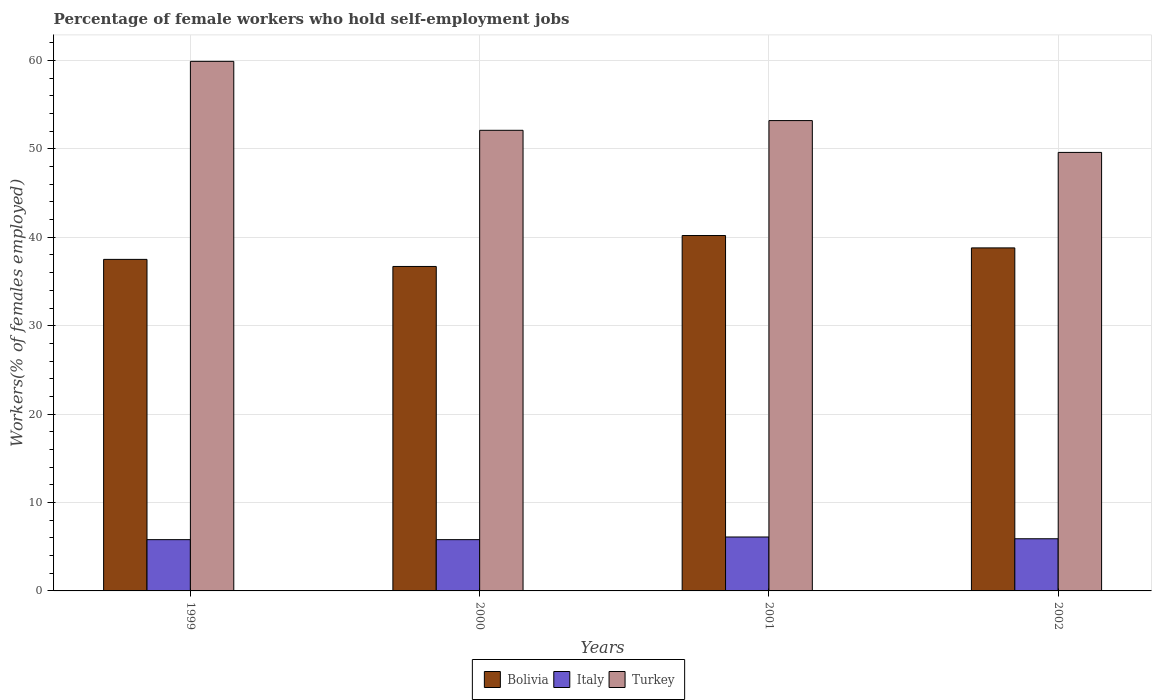How many different coloured bars are there?
Keep it short and to the point. 3. Are the number of bars on each tick of the X-axis equal?
Offer a terse response. Yes. How many bars are there on the 4th tick from the right?
Keep it short and to the point. 3. What is the percentage of self-employed female workers in Bolivia in 2001?
Your answer should be compact. 40.2. Across all years, what is the maximum percentage of self-employed female workers in Bolivia?
Your answer should be very brief. 40.2. Across all years, what is the minimum percentage of self-employed female workers in Italy?
Your answer should be very brief. 5.8. What is the total percentage of self-employed female workers in Turkey in the graph?
Make the answer very short. 214.8. What is the difference between the percentage of self-employed female workers in Turkey in 2000 and that in 2001?
Provide a succinct answer. -1.1. What is the difference between the percentage of self-employed female workers in Bolivia in 2000 and the percentage of self-employed female workers in Turkey in 2002?
Provide a short and direct response. -12.9. What is the average percentage of self-employed female workers in Bolivia per year?
Your answer should be very brief. 38.3. In the year 2000, what is the difference between the percentage of self-employed female workers in Turkey and percentage of self-employed female workers in Bolivia?
Make the answer very short. 15.4. In how many years, is the percentage of self-employed female workers in Turkey greater than 30 %?
Ensure brevity in your answer.  4. What is the ratio of the percentage of self-employed female workers in Bolivia in 1999 to that in 2000?
Your response must be concise. 1.02. Is the percentage of self-employed female workers in Italy in 2000 less than that in 2001?
Offer a very short reply. Yes. What is the difference between the highest and the second highest percentage of self-employed female workers in Italy?
Provide a succinct answer. 0.2. What does the 3rd bar from the right in 2000 represents?
Provide a short and direct response. Bolivia. Is it the case that in every year, the sum of the percentage of self-employed female workers in Turkey and percentage of self-employed female workers in Bolivia is greater than the percentage of self-employed female workers in Italy?
Your response must be concise. Yes. Are all the bars in the graph horizontal?
Provide a short and direct response. No. Does the graph contain any zero values?
Offer a terse response. No. Does the graph contain grids?
Offer a very short reply. Yes. How many legend labels are there?
Your answer should be compact. 3. How are the legend labels stacked?
Ensure brevity in your answer.  Horizontal. What is the title of the graph?
Ensure brevity in your answer.  Percentage of female workers who hold self-employment jobs. Does "Algeria" appear as one of the legend labels in the graph?
Keep it short and to the point. No. What is the label or title of the X-axis?
Ensure brevity in your answer.  Years. What is the label or title of the Y-axis?
Your response must be concise. Workers(% of females employed). What is the Workers(% of females employed) of Bolivia in 1999?
Provide a succinct answer. 37.5. What is the Workers(% of females employed) in Italy in 1999?
Your response must be concise. 5.8. What is the Workers(% of females employed) in Turkey in 1999?
Provide a short and direct response. 59.9. What is the Workers(% of females employed) of Bolivia in 2000?
Your answer should be very brief. 36.7. What is the Workers(% of females employed) of Italy in 2000?
Provide a succinct answer. 5.8. What is the Workers(% of females employed) in Turkey in 2000?
Offer a very short reply. 52.1. What is the Workers(% of females employed) of Bolivia in 2001?
Offer a very short reply. 40.2. What is the Workers(% of females employed) in Italy in 2001?
Provide a succinct answer. 6.1. What is the Workers(% of females employed) of Turkey in 2001?
Ensure brevity in your answer.  53.2. What is the Workers(% of females employed) in Bolivia in 2002?
Give a very brief answer. 38.8. What is the Workers(% of females employed) in Italy in 2002?
Make the answer very short. 5.9. What is the Workers(% of females employed) of Turkey in 2002?
Your answer should be compact. 49.6. Across all years, what is the maximum Workers(% of females employed) of Bolivia?
Your answer should be very brief. 40.2. Across all years, what is the maximum Workers(% of females employed) in Italy?
Ensure brevity in your answer.  6.1. Across all years, what is the maximum Workers(% of females employed) of Turkey?
Your answer should be very brief. 59.9. Across all years, what is the minimum Workers(% of females employed) of Bolivia?
Make the answer very short. 36.7. Across all years, what is the minimum Workers(% of females employed) of Italy?
Give a very brief answer. 5.8. Across all years, what is the minimum Workers(% of females employed) of Turkey?
Offer a very short reply. 49.6. What is the total Workers(% of females employed) of Bolivia in the graph?
Keep it short and to the point. 153.2. What is the total Workers(% of females employed) of Italy in the graph?
Make the answer very short. 23.6. What is the total Workers(% of females employed) of Turkey in the graph?
Give a very brief answer. 214.8. What is the difference between the Workers(% of females employed) in Bolivia in 1999 and that in 2000?
Offer a very short reply. 0.8. What is the difference between the Workers(% of females employed) of Turkey in 1999 and that in 2000?
Your response must be concise. 7.8. What is the difference between the Workers(% of females employed) of Italy in 1999 and that in 2001?
Give a very brief answer. -0.3. What is the difference between the Workers(% of females employed) in Turkey in 1999 and that in 2001?
Your answer should be very brief. 6.7. What is the difference between the Workers(% of females employed) of Bolivia in 1999 and that in 2002?
Keep it short and to the point. -1.3. What is the difference between the Workers(% of females employed) of Bolivia in 2000 and that in 2001?
Offer a terse response. -3.5. What is the difference between the Workers(% of females employed) in Italy in 2000 and that in 2001?
Ensure brevity in your answer.  -0.3. What is the difference between the Workers(% of females employed) of Bolivia in 2000 and that in 2002?
Your response must be concise. -2.1. What is the difference between the Workers(% of females employed) in Italy in 2000 and that in 2002?
Keep it short and to the point. -0.1. What is the difference between the Workers(% of females employed) in Turkey in 2001 and that in 2002?
Keep it short and to the point. 3.6. What is the difference between the Workers(% of females employed) of Bolivia in 1999 and the Workers(% of females employed) of Italy in 2000?
Your response must be concise. 31.7. What is the difference between the Workers(% of females employed) of Bolivia in 1999 and the Workers(% of females employed) of Turkey in 2000?
Provide a short and direct response. -14.6. What is the difference between the Workers(% of females employed) in Italy in 1999 and the Workers(% of females employed) in Turkey in 2000?
Offer a very short reply. -46.3. What is the difference between the Workers(% of females employed) in Bolivia in 1999 and the Workers(% of females employed) in Italy in 2001?
Ensure brevity in your answer.  31.4. What is the difference between the Workers(% of females employed) in Bolivia in 1999 and the Workers(% of females employed) in Turkey in 2001?
Offer a very short reply. -15.7. What is the difference between the Workers(% of females employed) in Italy in 1999 and the Workers(% of females employed) in Turkey in 2001?
Offer a terse response. -47.4. What is the difference between the Workers(% of females employed) of Bolivia in 1999 and the Workers(% of females employed) of Italy in 2002?
Keep it short and to the point. 31.6. What is the difference between the Workers(% of females employed) of Italy in 1999 and the Workers(% of females employed) of Turkey in 2002?
Offer a terse response. -43.8. What is the difference between the Workers(% of females employed) in Bolivia in 2000 and the Workers(% of females employed) in Italy in 2001?
Offer a terse response. 30.6. What is the difference between the Workers(% of females employed) in Bolivia in 2000 and the Workers(% of females employed) in Turkey in 2001?
Keep it short and to the point. -16.5. What is the difference between the Workers(% of females employed) in Italy in 2000 and the Workers(% of females employed) in Turkey in 2001?
Offer a terse response. -47.4. What is the difference between the Workers(% of females employed) in Bolivia in 2000 and the Workers(% of females employed) in Italy in 2002?
Provide a short and direct response. 30.8. What is the difference between the Workers(% of females employed) in Italy in 2000 and the Workers(% of females employed) in Turkey in 2002?
Your answer should be compact. -43.8. What is the difference between the Workers(% of females employed) in Bolivia in 2001 and the Workers(% of females employed) in Italy in 2002?
Your response must be concise. 34.3. What is the difference between the Workers(% of females employed) in Bolivia in 2001 and the Workers(% of females employed) in Turkey in 2002?
Ensure brevity in your answer.  -9.4. What is the difference between the Workers(% of females employed) in Italy in 2001 and the Workers(% of females employed) in Turkey in 2002?
Give a very brief answer. -43.5. What is the average Workers(% of females employed) of Bolivia per year?
Make the answer very short. 38.3. What is the average Workers(% of females employed) of Turkey per year?
Your answer should be very brief. 53.7. In the year 1999, what is the difference between the Workers(% of females employed) in Bolivia and Workers(% of females employed) in Italy?
Give a very brief answer. 31.7. In the year 1999, what is the difference between the Workers(% of females employed) in Bolivia and Workers(% of females employed) in Turkey?
Provide a short and direct response. -22.4. In the year 1999, what is the difference between the Workers(% of females employed) of Italy and Workers(% of females employed) of Turkey?
Make the answer very short. -54.1. In the year 2000, what is the difference between the Workers(% of females employed) in Bolivia and Workers(% of females employed) in Italy?
Provide a succinct answer. 30.9. In the year 2000, what is the difference between the Workers(% of females employed) in Bolivia and Workers(% of females employed) in Turkey?
Your response must be concise. -15.4. In the year 2000, what is the difference between the Workers(% of females employed) of Italy and Workers(% of females employed) of Turkey?
Your response must be concise. -46.3. In the year 2001, what is the difference between the Workers(% of females employed) in Bolivia and Workers(% of females employed) in Italy?
Offer a very short reply. 34.1. In the year 2001, what is the difference between the Workers(% of females employed) in Bolivia and Workers(% of females employed) in Turkey?
Your response must be concise. -13. In the year 2001, what is the difference between the Workers(% of females employed) of Italy and Workers(% of females employed) of Turkey?
Offer a terse response. -47.1. In the year 2002, what is the difference between the Workers(% of females employed) of Bolivia and Workers(% of females employed) of Italy?
Your answer should be compact. 32.9. In the year 2002, what is the difference between the Workers(% of females employed) of Italy and Workers(% of females employed) of Turkey?
Offer a terse response. -43.7. What is the ratio of the Workers(% of females employed) of Bolivia in 1999 to that in 2000?
Offer a very short reply. 1.02. What is the ratio of the Workers(% of females employed) in Turkey in 1999 to that in 2000?
Keep it short and to the point. 1.15. What is the ratio of the Workers(% of females employed) in Bolivia in 1999 to that in 2001?
Make the answer very short. 0.93. What is the ratio of the Workers(% of females employed) of Italy in 1999 to that in 2001?
Keep it short and to the point. 0.95. What is the ratio of the Workers(% of females employed) in Turkey in 1999 to that in 2001?
Keep it short and to the point. 1.13. What is the ratio of the Workers(% of females employed) of Bolivia in 1999 to that in 2002?
Your answer should be very brief. 0.97. What is the ratio of the Workers(% of females employed) in Italy in 1999 to that in 2002?
Give a very brief answer. 0.98. What is the ratio of the Workers(% of females employed) of Turkey in 1999 to that in 2002?
Your response must be concise. 1.21. What is the ratio of the Workers(% of females employed) in Bolivia in 2000 to that in 2001?
Provide a short and direct response. 0.91. What is the ratio of the Workers(% of females employed) of Italy in 2000 to that in 2001?
Make the answer very short. 0.95. What is the ratio of the Workers(% of females employed) in Turkey in 2000 to that in 2001?
Provide a short and direct response. 0.98. What is the ratio of the Workers(% of females employed) of Bolivia in 2000 to that in 2002?
Give a very brief answer. 0.95. What is the ratio of the Workers(% of females employed) in Italy in 2000 to that in 2002?
Ensure brevity in your answer.  0.98. What is the ratio of the Workers(% of females employed) of Turkey in 2000 to that in 2002?
Give a very brief answer. 1.05. What is the ratio of the Workers(% of females employed) in Bolivia in 2001 to that in 2002?
Provide a short and direct response. 1.04. What is the ratio of the Workers(% of females employed) in Italy in 2001 to that in 2002?
Make the answer very short. 1.03. What is the ratio of the Workers(% of females employed) of Turkey in 2001 to that in 2002?
Offer a very short reply. 1.07. What is the difference between the highest and the second highest Workers(% of females employed) in Italy?
Your answer should be compact. 0.2. What is the difference between the highest and the lowest Workers(% of females employed) in Bolivia?
Provide a short and direct response. 3.5. What is the difference between the highest and the lowest Workers(% of females employed) in Italy?
Your answer should be very brief. 0.3. 